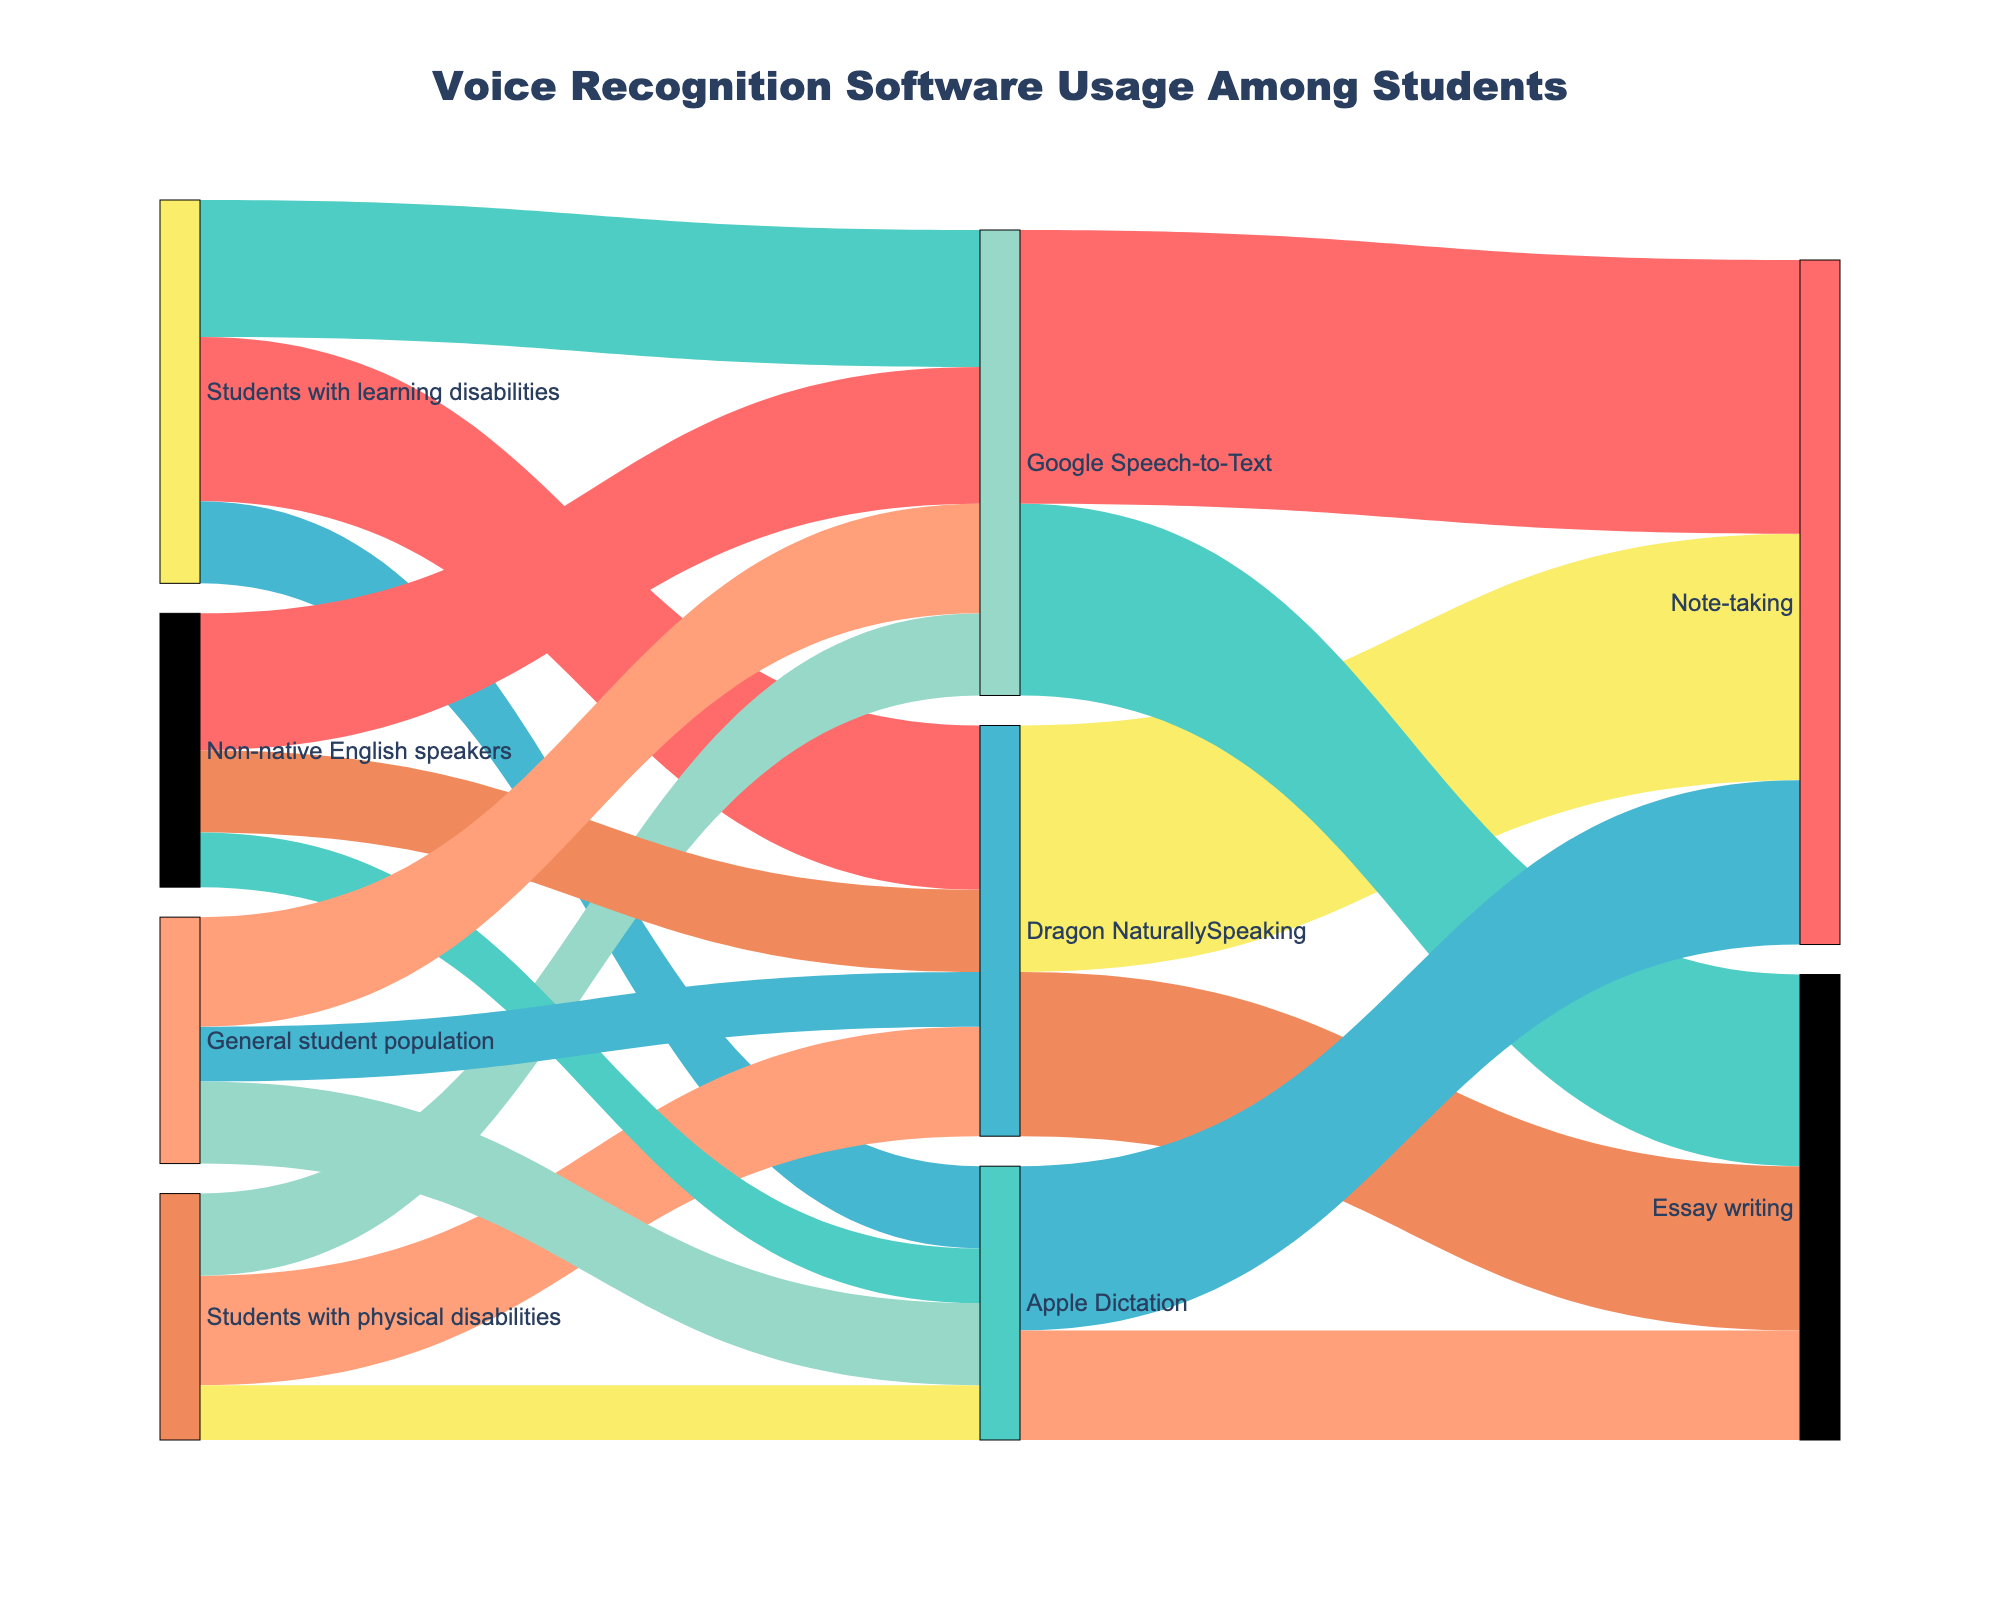How many students with learning disabilities use Dragon NaturallySpeaking? By observing the flow from "Students with learning disabilities" to "Dragon NaturallySpeaking," it is clear that 30 students use Dragon NaturallySpeaking.
Answer: 30 Which software is used by the majority of non-native English speakers? The largest flow from "Non-native English speakers" connects to "Google Speech-to-Text," indicating that 25 students use it, making it the most popular.
Answer: Google Speech-to-Text What is the total number of students using Apple Dictation? Summing the values flowing into "Apple Dictation" from various student groups: 15 (Students with learning disabilities) + 10 (Students with physical disabilities) + 10 (Non-native English speakers) + 15 (General student population) equals 50.
Answer: 50 Which application has the highest usage for note-taking? By comparing the values flowing into "Note-taking" from various software: Dragon NaturallySpeaking (45), Google Speech-to-Text (50), Apple Dictation (30). Google Speech-to-Text has the highest value of 50.
Answer: Google Speech-to-Text What is the difference in the number of students using Google Speech-to-Text between non-native English speakers and general student population? The number of non-native English speakers using Google Speech-to-Text is 25, and for the general student population, it is 20. The difference is 25 - 20 = 5.
Answer: 5 Compare the usage of Dragon NaturallySpeaking and Google Speech-to-Text among students with physical disabilities. The figures show that 20 students with physical disabilities use Dragon NaturallySpeaking, whereas 15 use Google Speech-to-Text, meaning Dragon NaturallySpeaking is more used by 5 students.
Answer: Dragon NaturallySpeaking What's the total number of students using voice recognition software for essay writing? Summing up the values flowing into "Essay writing" from different software: Dragon NaturallySpeaking (30) + Google Speech-to-Text (35) + Apple Dictation (20) equals 85.
Answer: 85 How many students use voice recognition software for note-taking? Summing up the values flowing into "Note-taking" from different software: Dragon NaturallySpeaking (45) + Google Speech-to-Text (50) + Apple Dictation (30) equals 125.
Answer: 125 